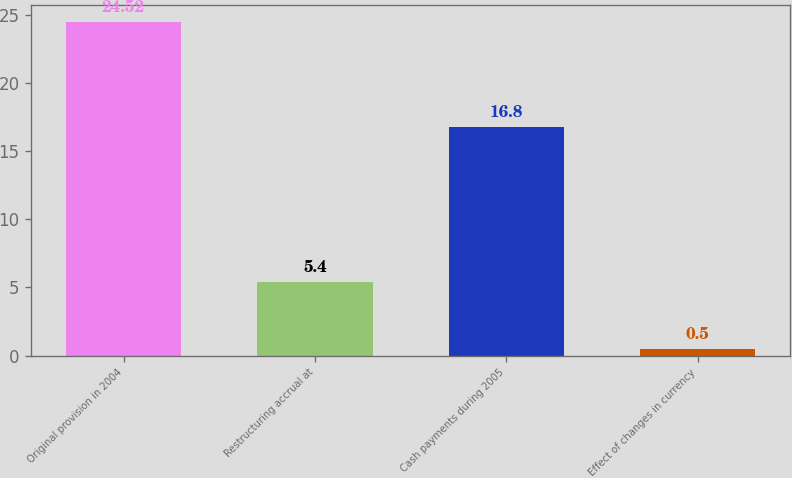Convert chart to OTSL. <chart><loc_0><loc_0><loc_500><loc_500><bar_chart><fcel>Original provision in 2004<fcel>Restructuring accrual at<fcel>Cash payments during 2005<fcel>Effect of changes in currency<nl><fcel>24.52<fcel>5.4<fcel>16.8<fcel>0.5<nl></chart> 